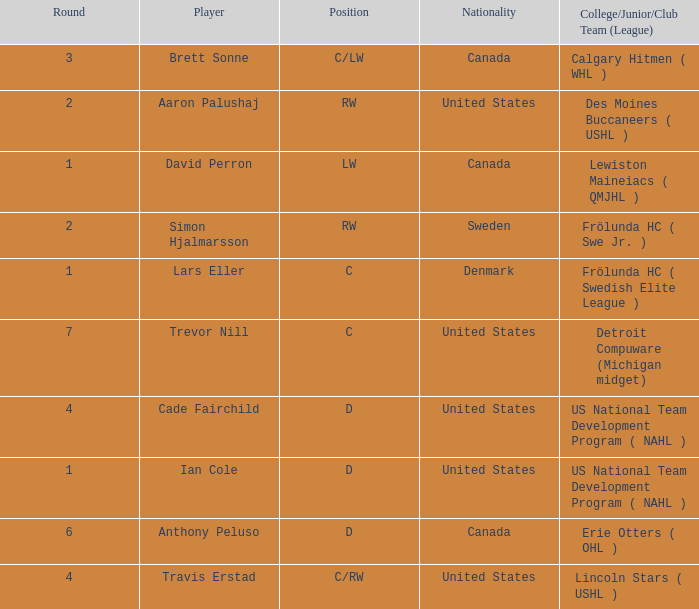What is the position of the player from round 2 from Sweden? RW. 